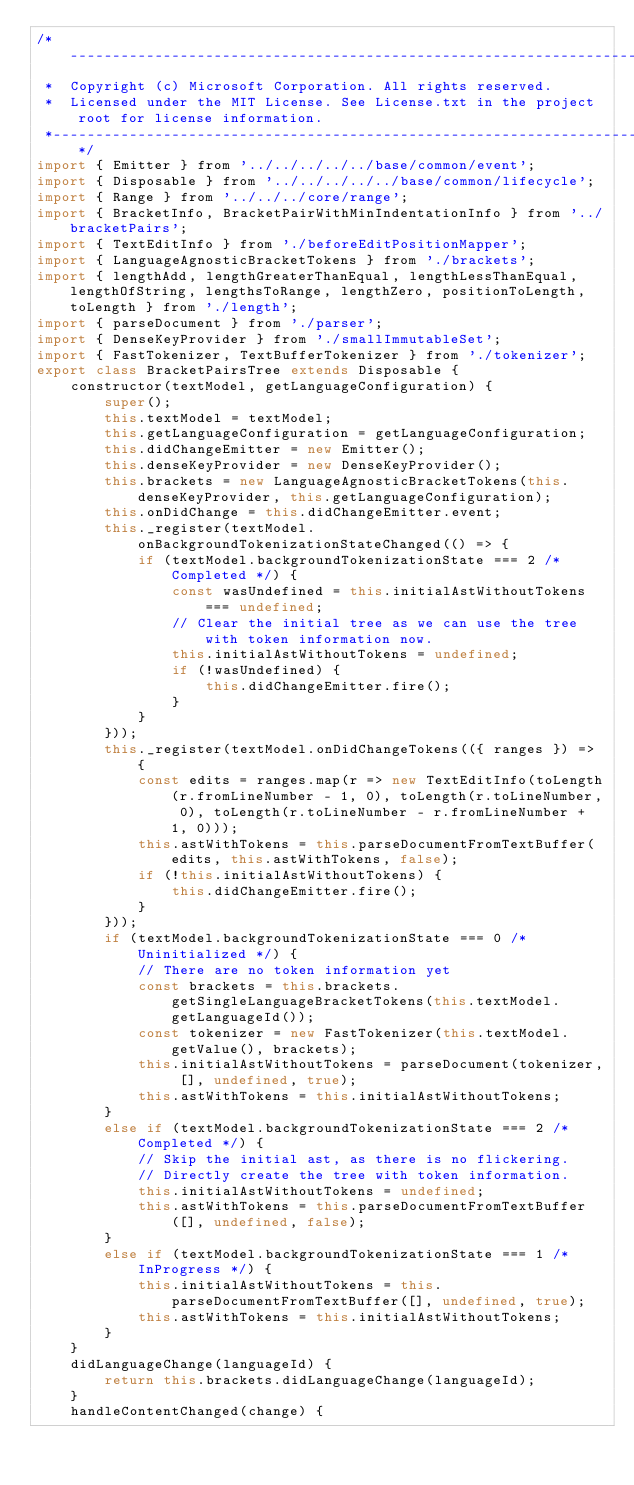<code> <loc_0><loc_0><loc_500><loc_500><_JavaScript_>/*---------------------------------------------------------------------------------------------
 *  Copyright (c) Microsoft Corporation. All rights reserved.
 *  Licensed under the MIT License. See License.txt in the project root for license information.
 *--------------------------------------------------------------------------------------------*/
import { Emitter } from '../../../../../base/common/event';
import { Disposable } from '../../../../../base/common/lifecycle';
import { Range } from '../../../core/range';
import { BracketInfo, BracketPairWithMinIndentationInfo } from '../bracketPairs';
import { TextEditInfo } from './beforeEditPositionMapper';
import { LanguageAgnosticBracketTokens } from './brackets';
import { lengthAdd, lengthGreaterThanEqual, lengthLessThanEqual, lengthOfString, lengthsToRange, lengthZero, positionToLength, toLength } from './length';
import { parseDocument } from './parser';
import { DenseKeyProvider } from './smallImmutableSet';
import { FastTokenizer, TextBufferTokenizer } from './tokenizer';
export class BracketPairsTree extends Disposable {
    constructor(textModel, getLanguageConfiguration) {
        super();
        this.textModel = textModel;
        this.getLanguageConfiguration = getLanguageConfiguration;
        this.didChangeEmitter = new Emitter();
        this.denseKeyProvider = new DenseKeyProvider();
        this.brackets = new LanguageAgnosticBracketTokens(this.denseKeyProvider, this.getLanguageConfiguration);
        this.onDidChange = this.didChangeEmitter.event;
        this._register(textModel.onBackgroundTokenizationStateChanged(() => {
            if (textModel.backgroundTokenizationState === 2 /* Completed */) {
                const wasUndefined = this.initialAstWithoutTokens === undefined;
                // Clear the initial tree as we can use the tree with token information now.
                this.initialAstWithoutTokens = undefined;
                if (!wasUndefined) {
                    this.didChangeEmitter.fire();
                }
            }
        }));
        this._register(textModel.onDidChangeTokens(({ ranges }) => {
            const edits = ranges.map(r => new TextEditInfo(toLength(r.fromLineNumber - 1, 0), toLength(r.toLineNumber, 0), toLength(r.toLineNumber - r.fromLineNumber + 1, 0)));
            this.astWithTokens = this.parseDocumentFromTextBuffer(edits, this.astWithTokens, false);
            if (!this.initialAstWithoutTokens) {
                this.didChangeEmitter.fire();
            }
        }));
        if (textModel.backgroundTokenizationState === 0 /* Uninitialized */) {
            // There are no token information yet
            const brackets = this.brackets.getSingleLanguageBracketTokens(this.textModel.getLanguageId());
            const tokenizer = new FastTokenizer(this.textModel.getValue(), brackets);
            this.initialAstWithoutTokens = parseDocument(tokenizer, [], undefined, true);
            this.astWithTokens = this.initialAstWithoutTokens;
        }
        else if (textModel.backgroundTokenizationState === 2 /* Completed */) {
            // Skip the initial ast, as there is no flickering.
            // Directly create the tree with token information.
            this.initialAstWithoutTokens = undefined;
            this.astWithTokens = this.parseDocumentFromTextBuffer([], undefined, false);
        }
        else if (textModel.backgroundTokenizationState === 1 /* InProgress */) {
            this.initialAstWithoutTokens = this.parseDocumentFromTextBuffer([], undefined, true);
            this.astWithTokens = this.initialAstWithoutTokens;
        }
    }
    didLanguageChange(languageId) {
        return this.brackets.didLanguageChange(languageId);
    }
    handleContentChanged(change) {</code> 